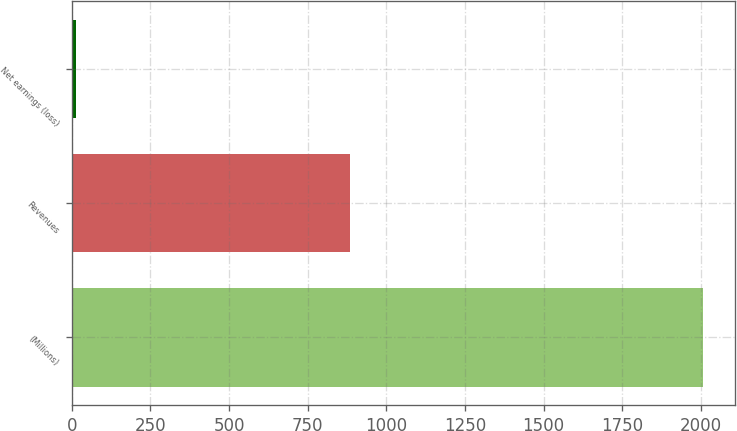Convert chart to OTSL. <chart><loc_0><loc_0><loc_500><loc_500><bar_chart><fcel>(Millions)<fcel>Revenues<fcel>Net earnings (loss)<nl><fcel>2008<fcel>885<fcel>14<nl></chart> 